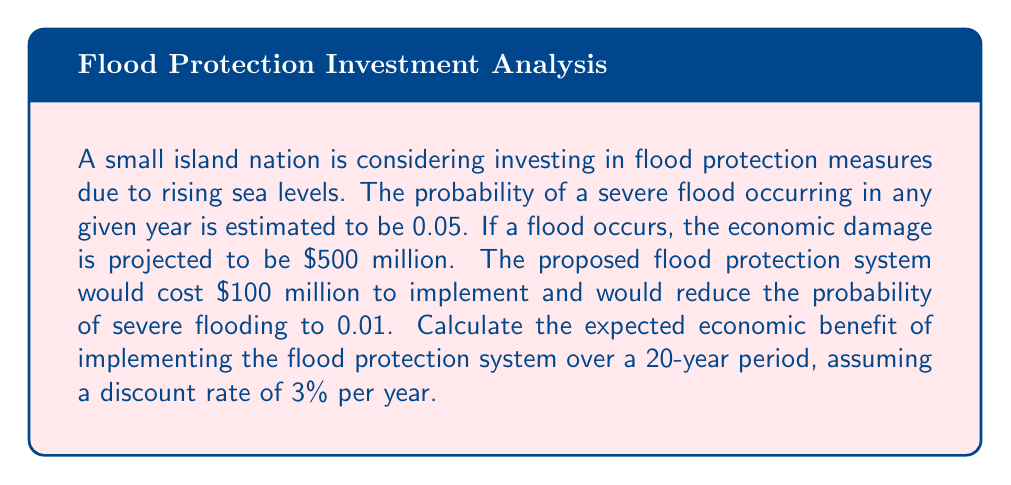What is the answer to this math problem? Let's approach this problem step-by-step:

1) First, calculate the expected annual loss without flood protection:
   $E(\text{Loss}) = 0.05 \times \$500\text{ million} = \$25\text{ million}$

2) With flood protection, the expected annual loss would be:
   $E(\text{Loss}_{\text{protected}}) = 0.01 \times \$500\text{ million} = \$5\text{ million}$

3) The annual benefit of the flood protection is the difference:
   $\text{Annual Benefit} = \$25\text{ million} - \$5\text{ million} = \$20\text{ million}$

4) To calculate the present value of this benefit over 20 years with a 3% discount rate, we use the present value annuity formula:

   $PV = A \times \frac{1 - (1+r)^{-n}}{r}$

   Where:
   $A = \$20\text{ million}$ (annual benefit)
   $r = 0.03$ (discount rate)
   $n = 20$ (number of years)

5) Plugging in the values:

   $PV = \$20\text{ million} \times \frac{1 - (1+0.03)^{-20}}{0.03}$

6) Calculating:
   $PV \approx \$297.39\text{ million}$

7) The net benefit is the present value of benefits minus the cost of implementation:
   $\text{Net Benefit} = \$297.39\text{ million} - \$100\text{ million} = \$197.39\text{ million}$
Answer: $197.39 million 